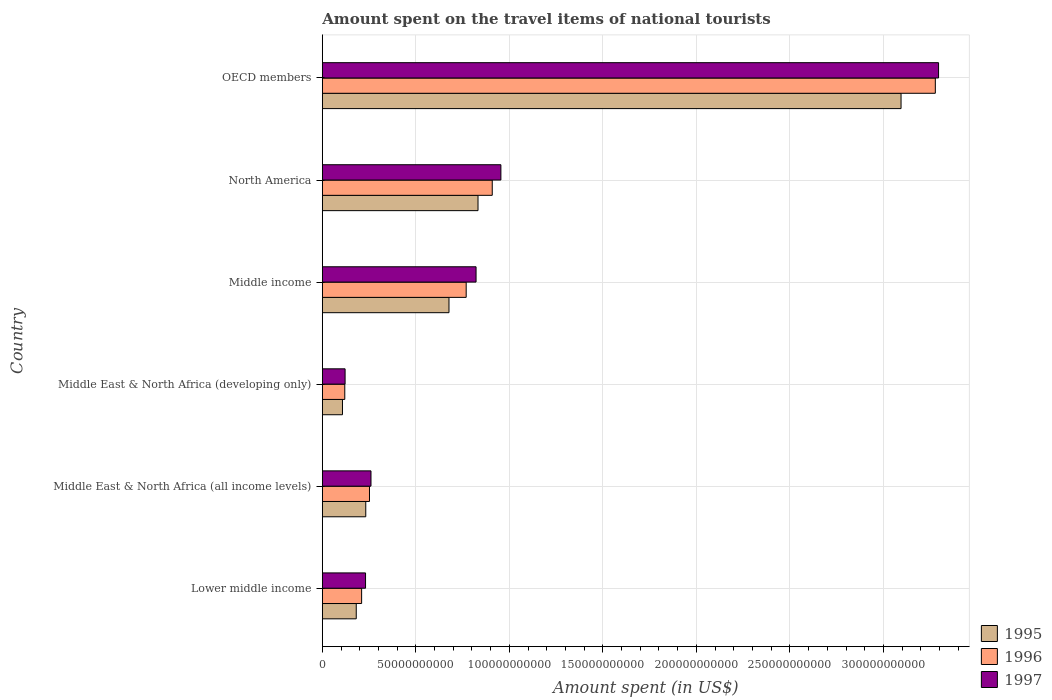How many groups of bars are there?
Give a very brief answer. 6. Are the number of bars on each tick of the Y-axis equal?
Ensure brevity in your answer.  Yes. In how many cases, is the number of bars for a given country not equal to the number of legend labels?
Ensure brevity in your answer.  0. What is the amount spent on the travel items of national tourists in 1996 in Lower middle income?
Provide a succinct answer. 2.10e+1. Across all countries, what is the maximum amount spent on the travel items of national tourists in 1997?
Your answer should be compact. 3.29e+11. Across all countries, what is the minimum amount spent on the travel items of national tourists in 1997?
Your response must be concise. 1.22e+1. In which country was the amount spent on the travel items of national tourists in 1996 maximum?
Your response must be concise. OECD members. In which country was the amount spent on the travel items of national tourists in 1995 minimum?
Provide a succinct answer. Middle East & North Africa (developing only). What is the total amount spent on the travel items of national tourists in 1996 in the graph?
Make the answer very short. 5.54e+11. What is the difference between the amount spent on the travel items of national tourists in 1997 in Middle East & North Africa (all income levels) and that in North America?
Give a very brief answer. -6.95e+1. What is the difference between the amount spent on the travel items of national tourists in 1997 in OECD members and the amount spent on the travel items of national tourists in 1995 in Middle East & North Africa (all income levels)?
Offer a very short reply. 3.06e+11. What is the average amount spent on the travel items of national tourists in 1995 per country?
Provide a succinct answer. 8.54e+1. What is the difference between the amount spent on the travel items of national tourists in 1997 and amount spent on the travel items of national tourists in 1995 in OECD members?
Ensure brevity in your answer.  2.01e+1. What is the ratio of the amount spent on the travel items of national tourists in 1997 in Middle East & North Africa (developing only) to that in North America?
Your response must be concise. 0.13. Is the amount spent on the travel items of national tourists in 1997 in Middle income less than that in North America?
Provide a short and direct response. Yes. What is the difference between the highest and the second highest amount spent on the travel items of national tourists in 1997?
Your response must be concise. 2.34e+11. What is the difference between the highest and the lowest amount spent on the travel items of national tourists in 1996?
Make the answer very short. 3.16e+11. Is the sum of the amount spent on the travel items of national tourists in 1995 in Middle income and North America greater than the maximum amount spent on the travel items of national tourists in 1996 across all countries?
Offer a terse response. No. What does the 1st bar from the top in Lower middle income represents?
Make the answer very short. 1997. What does the 2nd bar from the bottom in Middle East & North Africa (all income levels) represents?
Your response must be concise. 1996. How many bars are there?
Make the answer very short. 18. Are all the bars in the graph horizontal?
Your answer should be very brief. Yes. What is the difference between two consecutive major ticks on the X-axis?
Ensure brevity in your answer.  5.00e+1. Does the graph contain grids?
Ensure brevity in your answer.  Yes. How many legend labels are there?
Make the answer very short. 3. What is the title of the graph?
Offer a very short reply. Amount spent on the travel items of national tourists. Does "1996" appear as one of the legend labels in the graph?
Your answer should be compact. Yes. What is the label or title of the X-axis?
Give a very brief answer. Amount spent (in US$). What is the label or title of the Y-axis?
Make the answer very short. Country. What is the Amount spent (in US$) in 1995 in Lower middle income?
Keep it short and to the point. 1.81e+1. What is the Amount spent (in US$) of 1996 in Lower middle income?
Provide a succinct answer. 2.10e+1. What is the Amount spent (in US$) in 1997 in Lower middle income?
Provide a short and direct response. 2.31e+1. What is the Amount spent (in US$) in 1995 in Middle East & North Africa (all income levels)?
Your response must be concise. 2.32e+1. What is the Amount spent (in US$) in 1996 in Middle East & North Africa (all income levels)?
Offer a very short reply. 2.52e+1. What is the Amount spent (in US$) in 1997 in Middle East & North Africa (all income levels)?
Your answer should be compact. 2.60e+1. What is the Amount spent (in US$) in 1995 in Middle East & North Africa (developing only)?
Your answer should be compact. 1.08e+1. What is the Amount spent (in US$) in 1996 in Middle East & North Africa (developing only)?
Provide a short and direct response. 1.20e+1. What is the Amount spent (in US$) in 1997 in Middle East & North Africa (developing only)?
Ensure brevity in your answer.  1.22e+1. What is the Amount spent (in US$) of 1995 in Middle income?
Provide a succinct answer. 6.77e+1. What is the Amount spent (in US$) in 1996 in Middle income?
Offer a very short reply. 7.69e+1. What is the Amount spent (in US$) in 1997 in Middle income?
Your answer should be very brief. 8.22e+1. What is the Amount spent (in US$) in 1995 in North America?
Your answer should be compact. 8.32e+1. What is the Amount spent (in US$) of 1996 in North America?
Provide a short and direct response. 9.09e+1. What is the Amount spent (in US$) of 1997 in North America?
Your response must be concise. 9.55e+1. What is the Amount spent (in US$) of 1995 in OECD members?
Your answer should be very brief. 3.09e+11. What is the Amount spent (in US$) of 1996 in OECD members?
Your answer should be compact. 3.28e+11. What is the Amount spent (in US$) in 1997 in OECD members?
Give a very brief answer. 3.29e+11. Across all countries, what is the maximum Amount spent (in US$) of 1995?
Make the answer very short. 3.09e+11. Across all countries, what is the maximum Amount spent (in US$) of 1996?
Ensure brevity in your answer.  3.28e+11. Across all countries, what is the maximum Amount spent (in US$) of 1997?
Ensure brevity in your answer.  3.29e+11. Across all countries, what is the minimum Amount spent (in US$) of 1995?
Provide a short and direct response. 1.08e+1. Across all countries, what is the minimum Amount spent (in US$) of 1996?
Give a very brief answer. 1.20e+1. Across all countries, what is the minimum Amount spent (in US$) in 1997?
Offer a very short reply. 1.22e+1. What is the total Amount spent (in US$) of 1995 in the graph?
Provide a succinct answer. 5.13e+11. What is the total Amount spent (in US$) of 1996 in the graph?
Your response must be concise. 5.54e+11. What is the total Amount spent (in US$) in 1997 in the graph?
Provide a succinct answer. 5.68e+11. What is the difference between the Amount spent (in US$) in 1995 in Lower middle income and that in Middle East & North Africa (all income levels)?
Make the answer very short. -5.09e+09. What is the difference between the Amount spent (in US$) of 1996 in Lower middle income and that in Middle East & North Africa (all income levels)?
Offer a terse response. -4.20e+09. What is the difference between the Amount spent (in US$) of 1997 in Lower middle income and that in Middle East & North Africa (all income levels)?
Provide a short and direct response. -2.91e+09. What is the difference between the Amount spent (in US$) of 1995 in Lower middle income and that in Middle East & North Africa (developing only)?
Your response must be concise. 7.36e+09. What is the difference between the Amount spent (in US$) in 1996 in Lower middle income and that in Middle East & North Africa (developing only)?
Ensure brevity in your answer.  9.01e+09. What is the difference between the Amount spent (in US$) of 1997 in Lower middle income and that in Middle East & North Africa (developing only)?
Offer a very short reply. 1.09e+1. What is the difference between the Amount spent (in US$) in 1995 in Lower middle income and that in Middle income?
Offer a very short reply. -4.96e+1. What is the difference between the Amount spent (in US$) in 1996 in Lower middle income and that in Middle income?
Keep it short and to the point. -5.59e+1. What is the difference between the Amount spent (in US$) of 1997 in Lower middle income and that in Middle income?
Provide a short and direct response. -5.91e+1. What is the difference between the Amount spent (in US$) in 1995 in Lower middle income and that in North America?
Your response must be concise. -6.51e+1. What is the difference between the Amount spent (in US$) of 1996 in Lower middle income and that in North America?
Keep it short and to the point. -6.98e+1. What is the difference between the Amount spent (in US$) in 1997 in Lower middle income and that in North America?
Offer a terse response. -7.24e+1. What is the difference between the Amount spent (in US$) of 1995 in Lower middle income and that in OECD members?
Give a very brief answer. -2.91e+11. What is the difference between the Amount spent (in US$) of 1996 in Lower middle income and that in OECD members?
Offer a terse response. -3.07e+11. What is the difference between the Amount spent (in US$) of 1997 in Lower middle income and that in OECD members?
Your answer should be very brief. -3.06e+11. What is the difference between the Amount spent (in US$) of 1995 in Middle East & North Africa (all income levels) and that in Middle East & North Africa (developing only)?
Make the answer very short. 1.25e+1. What is the difference between the Amount spent (in US$) of 1996 in Middle East & North Africa (all income levels) and that in Middle East & North Africa (developing only)?
Your answer should be very brief. 1.32e+1. What is the difference between the Amount spent (in US$) of 1997 in Middle East & North Africa (all income levels) and that in Middle East & North Africa (developing only)?
Offer a very short reply. 1.38e+1. What is the difference between the Amount spent (in US$) in 1995 in Middle East & North Africa (all income levels) and that in Middle income?
Your answer should be compact. -4.45e+1. What is the difference between the Amount spent (in US$) of 1996 in Middle East & North Africa (all income levels) and that in Middle income?
Give a very brief answer. -5.17e+1. What is the difference between the Amount spent (in US$) of 1997 in Middle East & North Africa (all income levels) and that in Middle income?
Ensure brevity in your answer.  -5.62e+1. What is the difference between the Amount spent (in US$) of 1995 in Middle East & North Africa (all income levels) and that in North America?
Offer a terse response. -6.00e+1. What is the difference between the Amount spent (in US$) in 1996 in Middle East & North Africa (all income levels) and that in North America?
Ensure brevity in your answer.  -6.56e+1. What is the difference between the Amount spent (in US$) in 1997 in Middle East & North Africa (all income levels) and that in North America?
Offer a very short reply. -6.95e+1. What is the difference between the Amount spent (in US$) in 1995 in Middle East & North Africa (all income levels) and that in OECD members?
Offer a terse response. -2.86e+11. What is the difference between the Amount spent (in US$) in 1996 in Middle East & North Africa (all income levels) and that in OECD members?
Your answer should be very brief. -3.03e+11. What is the difference between the Amount spent (in US$) in 1997 in Middle East & North Africa (all income levels) and that in OECD members?
Your answer should be compact. -3.03e+11. What is the difference between the Amount spent (in US$) of 1995 in Middle East & North Africa (developing only) and that in Middle income?
Keep it short and to the point. -5.69e+1. What is the difference between the Amount spent (in US$) of 1996 in Middle East & North Africa (developing only) and that in Middle income?
Ensure brevity in your answer.  -6.49e+1. What is the difference between the Amount spent (in US$) of 1997 in Middle East & North Africa (developing only) and that in Middle income?
Provide a succinct answer. -7.00e+1. What is the difference between the Amount spent (in US$) of 1995 in Middle East & North Africa (developing only) and that in North America?
Ensure brevity in your answer.  -7.25e+1. What is the difference between the Amount spent (in US$) of 1996 in Middle East & North Africa (developing only) and that in North America?
Provide a short and direct response. -7.88e+1. What is the difference between the Amount spent (in US$) of 1997 in Middle East & North Africa (developing only) and that in North America?
Provide a short and direct response. -8.33e+1. What is the difference between the Amount spent (in US$) in 1995 in Middle East & North Africa (developing only) and that in OECD members?
Ensure brevity in your answer.  -2.99e+11. What is the difference between the Amount spent (in US$) in 1996 in Middle East & North Africa (developing only) and that in OECD members?
Make the answer very short. -3.16e+11. What is the difference between the Amount spent (in US$) of 1997 in Middle East & North Africa (developing only) and that in OECD members?
Make the answer very short. -3.17e+11. What is the difference between the Amount spent (in US$) in 1995 in Middle income and that in North America?
Provide a short and direct response. -1.55e+1. What is the difference between the Amount spent (in US$) in 1996 in Middle income and that in North America?
Your answer should be compact. -1.39e+1. What is the difference between the Amount spent (in US$) in 1997 in Middle income and that in North America?
Provide a succinct answer. -1.33e+1. What is the difference between the Amount spent (in US$) in 1995 in Middle income and that in OECD members?
Your answer should be compact. -2.42e+11. What is the difference between the Amount spent (in US$) in 1996 in Middle income and that in OECD members?
Give a very brief answer. -2.51e+11. What is the difference between the Amount spent (in US$) of 1997 in Middle income and that in OECD members?
Give a very brief answer. -2.47e+11. What is the difference between the Amount spent (in US$) of 1995 in North America and that in OECD members?
Offer a terse response. -2.26e+11. What is the difference between the Amount spent (in US$) of 1996 in North America and that in OECD members?
Your response must be concise. -2.37e+11. What is the difference between the Amount spent (in US$) in 1997 in North America and that in OECD members?
Give a very brief answer. -2.34e+11. What is the difference between the Amount spent (in US$) of 1995 in Lower middle income and the Amount spent (in US$) of 1996 in Middle East & North Africa (all income levels)?
Provide a succinct answer. -7.08e+09. What is the difference between the Amount spent (in US$) of 1995 in Lower middle income and the Amount spent (in US$) of 1997 in Middle East & North Africa (all income levels)?
Give a very brief answer. -7.88e+09. What is the difference between the Amount spent (in US$) in 1996 in Lower middle income and the Amount spent (in US$) in 1997 in Middle East & North Africa (all income levels)?
Provide a short and direct response. -5.00e+09. What is the difference between the Amount spent (in US$) in 1995 in Lower middle income and the Amount spent (in US$) in 1996 in Middle East & North Africa (developing only)?
Ensure brevity in your answer.  6.13e+09. What is the difference between the Amount spent (in US$) of 1995 in Lower middle income and the Amount spent (in US$) of 1997 in Middle East & North Africa (developing only)?
Provide a succinct answer. 5.97e+09. What is the difference between the Amount spent (in US$) in 1996 in Lower middle income and the Amount spent (in US$) in 1997 in Middle East & North Africa (developing only)?
Your answer should be compact. 8.84e+09. What is the difference between the Amount spent (in US$) in 1995 in Lower middle income and the Amount spent (in US$) in 1996 in Middle income?
Offer a terse response. -5.88e+1. What is the difference between the Amount spent (in US$) in 1995 in Lower middle income and the Amount spent (in US$) in 1997 in Middle income?
Your answer should be compact. -6.41e+1. What is the difference between the Amount spent (in US$) in 1996 in Lower middle income and the Amount spent (in US$) in 1997 in Middle income?
Ensure brevity in your answer.  -6.12e+1. What is the difference between the Amount spent (in US$) in 1995 in Lower middle income and the Amount spent (in US$) in 1996 in North America?
Provide a succinct answer. -7.27e+1. What is the difference between the Amount spent (in US$) of 1995 in Lower middle income and the Amount spent (in US$) of 1997 in North America?
Provide a short and direct response. -7.73e+1. What is the difference between the Amount spent (in US$) of 1996 in Lower middle income and the Amount spent (in US$) of 1997 in North America?
Your answer should be very brief. -7.45e+1. What is the difference between the Amount spent (in US$) of 1995 in Lower middle income and the Amount spent (in US$) of 1996 in OECD members?
Provide a succinct answer. -3.10e+11. What is the difference between the Amount spent (in US$) in 1995 in Lower middle income and the Amount spent (in US$) in 1997 in OECD members?
Provide a short and direct response. -3.11e+11. What is the difference between the Amount spent (in US$) in 1996 in Lower middle income and the Amount spent (in US$) in 1997 in OECD members?
Give a very brief answer. -3.08e+11. What is the difference between the Amount spent (in US$) of 1995 in Middle East & North Africa (all income levels) and the Amount spent (in US$) of 1996 in Middle East & North Africa (developing only)?
Provide a succinct answer. 1.12e+1. What is the difference between the Amount spent (in US$) of 1995 in Middle East & North Africa (all income levels) and the Amount spent (in US$) of 1997 in Middle East & North Africa (developing only)?
Offer a terse response. 1.11e+1. What is the difference between the Amount spent (in US$) in 1996 in Middle East & North Africa (all income levels) and the Amount spent (in US$) in 1997 in Middle East & North Africa (developing only)?
Keep it short and to the point. 1.30e+1. What is the difference between the Amount spent (in US$) of 1995 in Middle East & North Africa (all income levels) and the Amount spent (in US$) of 1996 in Middle income?
Make the answer very short. -5.37e+1. What is the difference between the Amount spent (in US$) of 1995 in Middle East & North Africa (all income levels) and the Amount spent (in US$) of 1997 in Middle income?
Make the answer very short. -5.90e+1. What is the difference between the Amount spent (in US$) in 1996 in Middle East & North Africa (all income levels) and the Amount spent (in US$) in 1997 in Middle income?
Provide a short and direct response. -5.70e+1. What is the difference between the Amount spent (in US$) in 1995 in Middle East & North Africa (all income levels) and the Amount spent (in US$) in 1996 in North America?
Make the answer very short. -6.76e+1. What is the difference between the Amount spent (in US$) of 1995 in Middle East & North Africa (all income levels) and the Amount spent (in US$) of 1997 in North America?
Offer a terse response. -7.22e+1. What is the difference between the Amount spent (in US$) in 1996 in Middle East & North Africa (all income levels) and the Amount spent (in US$) in 1997 in North America?
Make the answer very short. -7.03e+1. What is the difference between the Amount spent (in US$) of 1995 in Middle East & North Africa (all income levels) and the Amount spent (in US$) of 1996 in OECD members?
Offer a terse response. -3.05e+11. What is the difference between the Amount spent (in US$) in 1995 in Middle East & North Africa (all income levels) and the Amount spent (in US$) in 1997 in OECD members?
Offer a very short reply. -3.06e+11. What is the difference between the Amount spent (in US$) of 1996 in Middle East & North Africa (all income levels) and the Amount spent (in US$) of 1997 in OECD members?
Give a very brief answer. -3.04e+11. What is the difference between the Amount spent (in US$) in 1995 in Middle East & North Africa (developing only) and the Amount spent (in US$) in 1996 in Middle income?
Make the answer very short. -6.61e+1. What is the difference between the Amount spent (in US$) of 1995 in Middle East & North Africa (developing only) and the Amount spent (in US$) of 1997 in Middle income?
Offer a terse response. -7.14e+1. What is the difference between the Amount spent (in US$) in 1996 in Middle East & North Africa (developing only) and the Amount spent (in US$) in 1997 in Middle income?
Your answer should be very brief. -7.02e+1. What is the difference between the Amount spent (in US$) in 1995 in Middle East & North Africa (developing only) and the Amount spent (in US$) in 1996 in North America?
Your answer should be very brief. -8.01e+1. What is the difference between the Amount spent (in US$) in 1995 in Middle East & North Africa (developing only) and the Amount spent (in US$) in 1997 in North America?
Offer a very short reply. -8.47e+1. What is the difference between the Amount spent (in US$) in 1996 in Middle East & North Africa (developing only) and the Amount spent (in US$) in 1997 in North America?
Offer a very short reply. -8.35e+1. What is the difference between the Amount spent (in US$) in 1995 in Middle East & North Africa (developing only) and the Amount spent (in US$) in 1996 in OECD members?
Offer a terse response. -3.17e+11. What is the difference between the Amount spent (in US$) in 1995 in Middle East & North Africa (developing only) and the Amount spent (in US$) in 1997 in OECD members?
Offer a very short reply. -3.19e+11. What is the difference between the Amount spent (in US$) of 1996 in Middle East & North Africa (developing only) and the Amount spent (in US$) of 1997 in OECD members?
Make the answer very short. -3.17e+11. What is the difference between the Amount spent (in US$) in 1995 in Middle income and the Amount spent (in US$) in 1996 in North America?
Your answer should be compact. -2.31e+1. What is the difference between the Amount spent (in US$) in 1995 in Middle income and the Amount spent (in US$) in 1997 in North America?
Provide a succinct answer. -2.78e+1. What is the difference between the Amount spent (in US$) in 1996 in Middle income and the Amount spent (in US$) in 1997 in North America?
Provide a succinct answer. -1.86e+1. What is the difference between the Amount spent (in US$) of 1995 in Middle income and the Amount spent (in US$) of 1996 in OECD members?
Your response must be concise. -2.60e+11. What is the difference between the Amount spent (in US$) in 1995 in Middle income and the Amount spent (in US$) in 1997 in OECD members?
Make the answer very short. -2.62e+11. What is the difference between the Amount spent (in US$) of 1996 in Middle income and the Amount spent (in US$) of 1997 in OECD members?
Your answer should be very brief. -2.53e+11. What is the difference between the Amount spent (in US$) of 1995 in North America and the Amount spent (in US$) of 1996 in OECD members?
Provide a succinct answer. -2.45e+11. What is the difference between the Amount spent (in US$) in 1995 in North America and the Amount spent (in US$) in 1997 in OECD members?
Your answer should be compact. -2.46e+11. What is the difference between the Amount spent (in US$) of 1996 in North America and the Amount spent (in US$) of 1997 in OECD members?
Ensure brevity in your answer.  -2.39e+11. What is the average Amount spent (in US$) of 1995 per country?
Make the answer very short. 8.54e+1. What is the average Amount spent (in US$) in 1996 per country?
Keep it short and to the point. 9.23e+1. What is the average Amount spent (in US$) in 1997 per country?
Make the answer very short. 9.47e+1. What is the difference between the Amount spent (in US$) of 1995 and Amount spent (in US$) of 1996 in Lower middle income?
Your response must be concise. -2.88e+09. What is the difference between the Amount spent (in US$) in 1995 and Amount spent (in US$) in 1997 in Lower middle income?
Give a very brief answer. -4.97e+09. What is the difference between the Amount spent (in US$) of 1996 and Amount spent (in US$) of 1997 in Lower middle income?
Provide a short and direct response. -2.09e+09. What is the difference between the Amount spent (in US$) in 1995 and Amount spent (in US$) in 1996 in Middle East & North Africa (all income levels)?
Offer a terse response. -1.99e+09. What is the difference between the Amount spent (in US$) of 1995 and Amount spent (in US$) of 1997 in Middle East & North Africa (all income levels)?
Your answer should be very brief. -2.79e+09. What is the difference between the Amount spent (in US$) of 1996 and Amount spent (in US$) of 1997 in Middle East & North Africa (all income levels)?
Provide a succinct answer. -7.97e+08. What is the difference between the Amount spent (in US$) in 1995 and Amount spent (in US$) in 1996 in Middle East & North Africa (developing only)?
Your response must be concise. -1.24e+09. What is the difference between the Amount spent (in US$) in 1995 and Amount spent (in US$) in 1997 in Middle East & North Africa (developing only)?
Your answer should be compact. -1.40e+09. What is the difference between the Amount spent (in US$) of 1996 and Amount spent (in US$) of 1997 in Middle East & North Africa (developing only)?
Your answer should be very brief. -1.61e+08. What is the difference between the Amount spent (in US$) in 1995 and Amount spent (in US$) in 1996 in Middle income?
Ensure brevity in your answer.  -9.19e+09. What is the difference between the Amount spent (in US$) in 1995 and Amount spent (in US$) in 1997 in Middle income?
Your answer should be very brief. -1.45e+1. What is the difference between the Amount spent (in US$) of 1996 and Amount spent (in US$) of 1997 in Middle income?
Your answer should be very brief. -5.28e+09. What is the difference between the Amount spent (in US$) in 1995 and Amount spent (in US$) in 1996 in North America?
Give a very brief answer. -7.61e+09. What is the difference between the Amount spent (in US$) in 1995 and Amount spent (in US$) in 1997 in North America?
Your answer should be compact. -1.22e+1. What is the difference between the Amount spent (in US$) in 1996 and Amount spent (in US$) in 1997 in North America?
Ensure brevity in your answer.  -4.62e+09. What is the difference between the Amount spent (in US$) in 1995 and Amount spent (in US$) in 1996 in OECD members?
Ensure brevity in your answer.  -1.83e+1. What is the difference between the Amount spent (in US$) in 1995 and Amount spent (in US$) in 1997 in OECD members?
Ensure brevity in your answer.  -2.01e+1. What is the difference between the Amount spent (in US$) of 1996 and Amount spent (in US$) of 1997 in OECD members?
Provide a short and direct response. -1.72e+09. What is the ratio of the Amount spent (in US$) of 1995 in Lower middle income to that in Middle East & North Africa (all income levels)?
Make the answer very short. 0.78. What is the ratio of the Amount spent (in US$) in 1997 in Lower middle income to that in Middle East & North Africa (all income levels)?
Provide a succinct answer. 0.89. What is the ratio of the Amount spent (in US$) of 1995 in Lower middle income to that in Middle East & North Africa (developing only)?
Offer a very short reply. 1.68. What is the ratio of the Amount spent (in US$) of 1996 in Lower middle income to that in Middle East & North Africa (developing only)?
Provide a short and direct response. 1.75. What is the ratio of the Amount spent (in US$) of 1997 in Lower middle income to that in Middle East & North Africa (developing only)?
Keep it short and to the point. 1.9. What is the ratio of the Amount spent (in US$) in 1995 in Lower middle income to that in Middle income?
Your answer should be compact. 0.27. What is the ratio of the Amount spent (in US$) in 1996 in Lower middle income to that in Middle income?
Keep it short and to the point. 0.27. What is the ratio of the Amount spent (in US$) in 1997 in Lower middle income to that in Middle income?
Your response must be concise. 0.28. What is the ratio of the Amount spent (in US$) in 1995 in Lower middle income to that in North America?
Your response must be concise. 0.22. What is the ratio of the Amount spent (in US$) in 1996 in Lower middle income to that in North America?
Ensure brevity in your answer.  0.23. What is the ratio of the Amount spent (in US$) of 1997 in Lower middle income to that in North America?
Offer a terse response. 0.24. What is the ratio of the Amount spent (in US$) in 1995 in Lower middle income to that in OECD members?
Give a very brief answer. 0.06. What is the ratio of the Amount spent (in US$) of 1996 in Lower middle income to that in OECD members?
Provide a short and direct response. 0.06. What is the ratio of the Amount spent (in US$) in 1997 in Lower middle income to that in OECD members?
Give a very brief answer. 0.07. What is the ratio of the Amount spent (in US$) of 1995 in Middle East & North Africa (all income levels) to that in Middle East & North Africa (developing only)?
Make the answer very short. 2.16. What is the ratio of the Amount spent (in US$) of 1996 in Middle East & North Africa (all income levels) to that in Middle East & North Africa (developing only)?
Your answer should be very brief. 2.1. What is the ratio of the Amount spent (in US$) in 1997 in Middle East & North Africa (all income levels) to that in Middle East & North Africa (developing only)?
Make the answer very short. 2.14. What is the ratio of the Amount spent (in US$) in 1995 in Middle East & North Africa (all income levels) to that in Middle income?
Your answer should be very brief. 0.34. What is the ratio of the Amount spent (in US$) in 1996 in Middle East & North Africa (all income levels) to that in Middle income?
Make the answer very short. 0.33. What is the ratio of the Amount spent (in US$) of 1997 in Middle East & North Africa (all income levels) to that in Middle income?
Provide a succinct answer. 0.32. What is the ratio of the Amount spent (in US$) of 1995 in Middle East & North Africa (all income levels) to that in North America?
Offer a terse response. 0.28. What is the ratio of the Amount spent (in US$) in 1996 in Middle East & North Africa (all income levels) to that in North America?
Offer a very short reply. 0.28. What is the ratio of the Amount spent (in US$) of 1997 in Middle East & North Africa (all income levels) to that in North America?
Offer a terse response. 0.27. What is the ratio of the Amount spent (in US$) in 1995 in Middle East & North Africa (all income levels) to that in OECD members?
Provide a short and direct response. 0.08. What is the ratio of the Amount spent (in US$) in 1996 in Middle East & North Africa (all income levels) to that in OECD members?
Provide a short and direct response. 0.08. What is the ratio of the Amount spent (in US$) of 1997 in Middle East & North Africa (all income levels) to that in OECD members?
Offer a terse response. 0.08. What is the ratio of the Amount spent (in US$) in 1995 in Middle East & North Africa (developing only) to that in Middle income?
Offer a terse response. 0.16. What is the ratio of the Amount spent (in US$) of 1996 in Middle East & North Africa (developing only) to that in Middle income?
Your response must be concise. 0.16. What is the ratio of the Amount spent (in US$) in 1997 in Middle East & North Africa (developing only) to that in Middle income?
Your answer should be compact. 0.15. What is the ratio of the Amount spent (in US$) in 1995 in Middle East & North Africa (developing only) to that in North America?
Keep it short and to the point. 0.13. What is the ratio of the Amount spent (in US$) of 1996 in Middle East & North Africa (developing only) to that in North America?
Provide a succinct answer. 0.13. What is the ratio of the Amount spent (in US$) of 1997 in Middle East & North Africa (developing only) to that in North America?
Offer a very short reply. 0.13. What is the ratio of the Amount spent (in US$) in 1995 in Middle East & North Africa (developing only) to that in OECD members?
Ensure brevity in your answer.  0.03. What is the ratio of the Amount spent (in US$) in 1996 in Middle East & North Africa (developing only) to that in OECD members?
Make the answer very short. 0.04. What is the ratio of the Amount spent (in US$) of 1997 in Middle East & North Africa (developing only) to that in OECD members?
Make the answer very short. 0.04. What is the ratio of the Amount spent (in US$) in 1995 in Middle income to that in North America?
Make the answer very short. 0.81. What is the ratio of the Amount spent (in US$) in 1996 in Middle income to that in North America?
Your answer should be compact. 0.85. What is the ratio of the Amount spent (in US$) in 1997 in Middle income to that in North America?
Keep it short and to the point. 0.86. What is the ratio of the Amount spent (in US$) in 1995 in Middle income to that in OECD members?
Your answer should be very brief. 0.22. What is the ratio of the Amount spent (in US$) of 1996 in Middle income to that in OECD members?
Offer a terse response. 0.23. What is the ratio of the Amount spent (in US$) of 1997 in Middle income to that in OECD members?
Offer a very short reply. 0.25. What is the ratio of the Amount spent (in US$) of 1995 in North America to that in OECD members?
Your answer should be compact. 0.27. What is the ratio of the Amount spent (in US$) of 1996 in North America to that in OECD members?
Give a very brief answer. 0.28. What is the ratio of the Amount spent (in US$) of 1997 in North America to that in OECD members?
Provide a short and direct response. 0.29. What is the difference between the highest and the second highest Amount spent (in US$) in 1995?
Provide a short and direct response. 2.26e+11. What is the difference between the highest and the second highest Amount spent (in US$) in 1996?
Your answer should be compact. 2.37e+11. What is the difference between the highest and the second highest Amount spent (in US$) in 1997?
Provide a succinct answer. 2.34e+11. What is the difference between the highest and the lowest Amount spent (in US$) in 1995?
Ensure brevity in your answer.  2.99e+11. What is the difference between the highest and the lowest Amount spent (in US$) of 1996?
Provide a succinct answer. 3.16e+11. What is the difference between the highest and the lowest Amount spent (in US$) of 1997?
Offer a very short reply. 3.17e+11. 